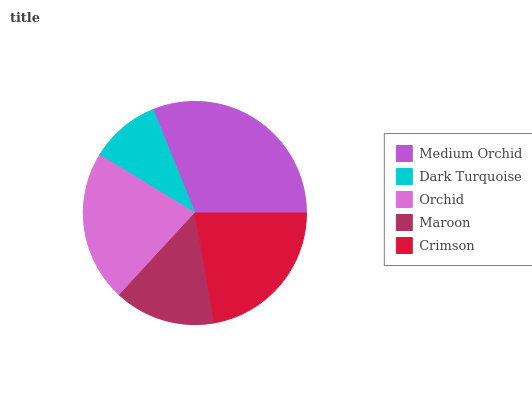Is Dark Turquoise the minimum?
Answer yes or no. Yes. Is Medium Orchid the maximum?
Answer yes or no. Yes. Is Orchid the minimum?
Answer yes or no. No. Is Orchid the maximum?
Answer yes or no. No. Is Orchid greater than Dark Turquoise?
Answer yes or no. Yes. Is Dark Turquoise less than Orchid?
Answer yes or no. Yes. Is Dark Turquoise greater than Orchid?
Answer yes or no. No. Is Orchid less than Dark Turquoise?
Answer yes or no. No. Is Orchid the high median?
Answer yes or no. Yes. Is Orchid the low median?
Answer yes or no. Yes. Is Crimson the high median?
Answer yes or no. No. Is Maroon the low median?
Answer yes or no. No. 